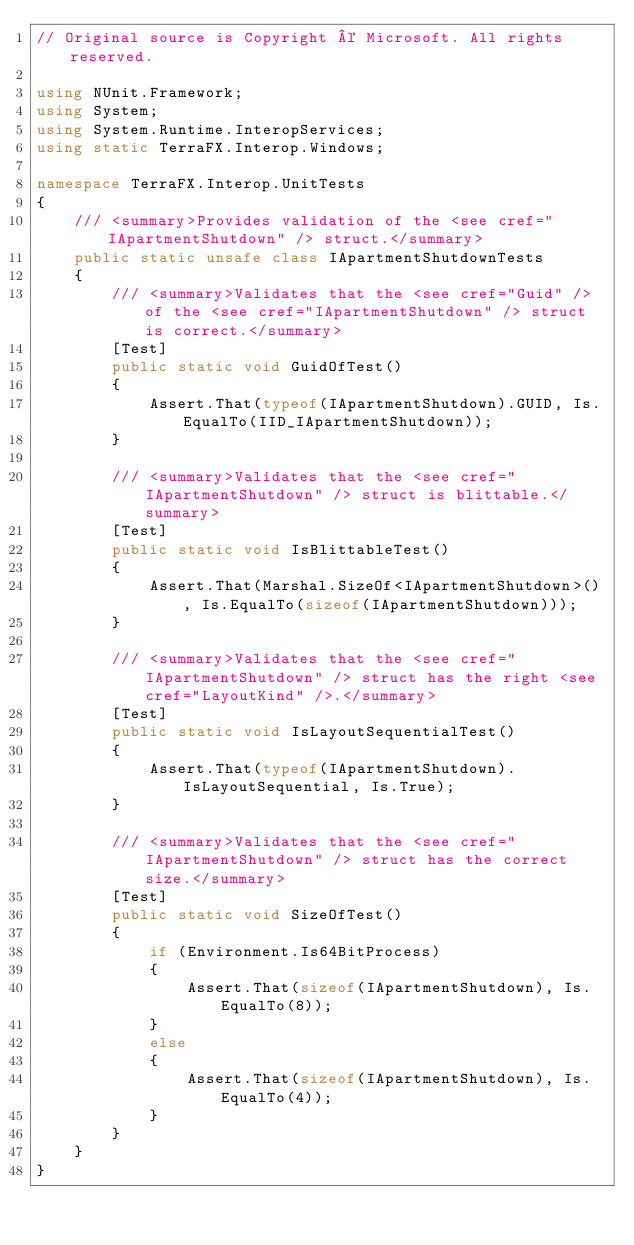<code> <loc_0><loc_0><loc_500><loc_500><_C#_>// Original source is Copyright © Microsoft. All rights reserved.

using NUnit.Framework;
using System;
using System.Runtime.InteropServices;
using static TerraFX.Interop.Windows;

namespace TerraFX.Interop.UnitTests
{
    /// <summary>Provides validation of the <see cref="IApartmentShutdown" /> struct.</summary>
    public static unsafe class IApartmentShutdownTests
    {
        /// <summary>Validates that the <see cref="Guid" /> of the <see cref="IApartmentShutdown" /> struct is correct.</summary>
        [Test]
        public static void GuidOfTest()
        {
            Assert.That(typeof(IApartmentShutdown).GUID, Is.EqualTo(IID_IApartmentShutdown));
        }

        /// <summary>Validates that the <see cref="IApartmentShutdown" /> struct is blittable.</summary>
        [Test]
        public static void IsBlittableTest()
        {
            Assert.That(Marshal.SizeOf<IApartmentShutdown>(), Is.EqualTo(sizeof(IApartmentShutdown)));
        }

        /// <summary>Validates that the <see cref="IApartmentShutdown" /> struct has the right <see cref="LayoutKind" />.</summary>
        [Test]
        public static void IsLayoutSequentialTest()
        {
            Assert.That(typeof(IApartmentShutdown).IsLayoutSequential, Is.True);
        }

        /// <summary>Validates that the <see cref="IApartmentShutdown" /> struct has the correct size.</summary>
        [Test]
        public static void SizeOfTest()
        {
            if (Environment.Is64BitProcess)
            {
                Assert.That(sizeof(IApartmentShutdown), Is.EqualTo(8));
            }
            else
            {
                Assert.That(sizeof(IApartmentShutdown), Is.EqualTo(4));
            }
        }
    }
}
</code> 